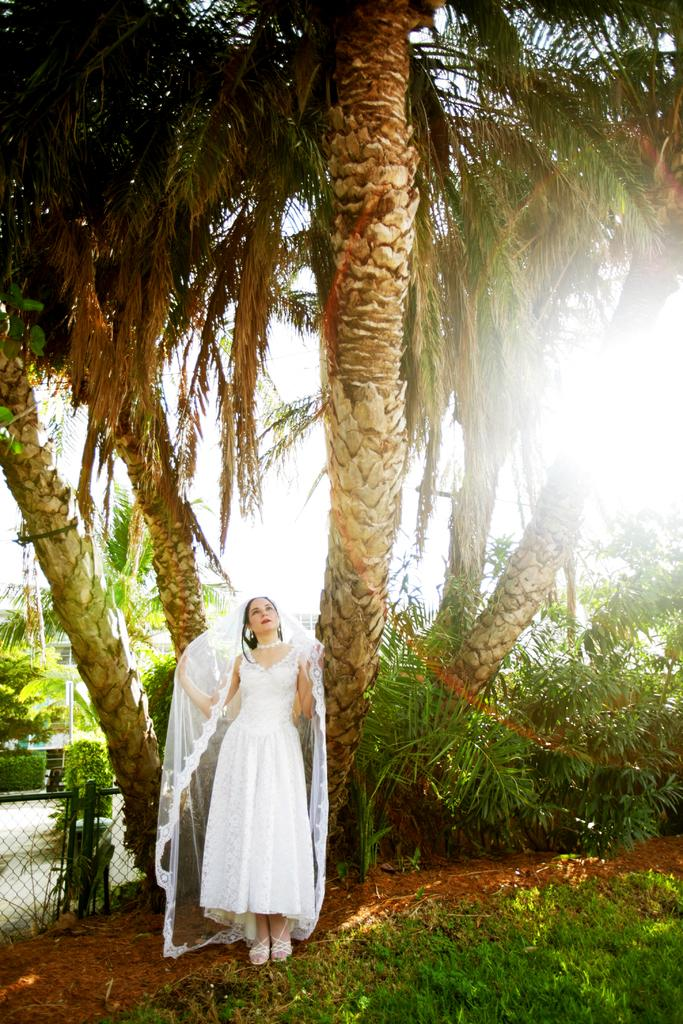What is the main subject of the image? There is a woman standing in the image. What is the woman standing on? The woman is standing on the ground. What type of vegetation can be seen in the image? There is grass, plants, and trees visible in the image. What is the background of the image? The sky is visible in the background of the image. Are there any structures or objects in the image? Yes, there is a fence in the image. What type of card is the woman holding in the image? There is no card present in the image; the woman is not holding anything. Can you describe the cream on the woman's hand in the image? There is no cream on the woman's hand in the image. 